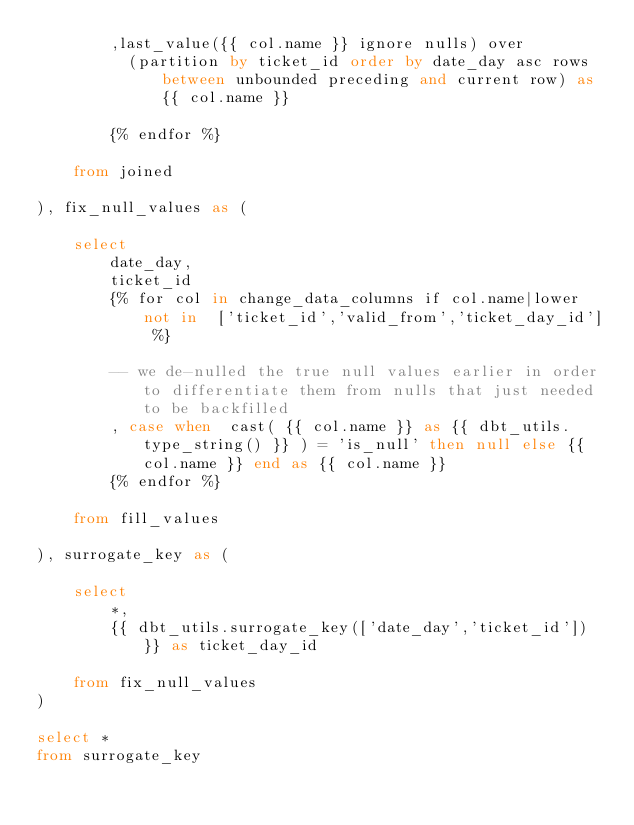<code> <loc_0><loc_0><loc_500><loc_500><_SQL_>        ,last_value({{ col.name }} ignore nulls) over 
          (partition by ticket_id order by date_day asc rows between unbounded preceding and current row) as {{ col.name }}

        {% endfor %}

    from joined

), fix_null_values as (

    select  
        date_day,
        ticket_id
        {% for col in change_data_columns if col.name|lower not in  ['ticket_id','valid_from','ticket_day_id'] %} 

        -- we de-nulled the true null values earlier in order to differentiate them from nulls that just needed to be backfilled
        , case when  cast( {{ col.name }} as {{ dbt_utils.type_string() }} ) = 'is_null' then null else {{ col.name }} end as {{ col.name }}
        {% endfor %}

    from fill_values

), surrogate_key as (

    select
        *,
        {{ dbt_utils.surrogate_key(['date_day','ticket_id']) }} as ticket_day_id

    from fix_null_values
)

select *
from surrogate_key
</code> 